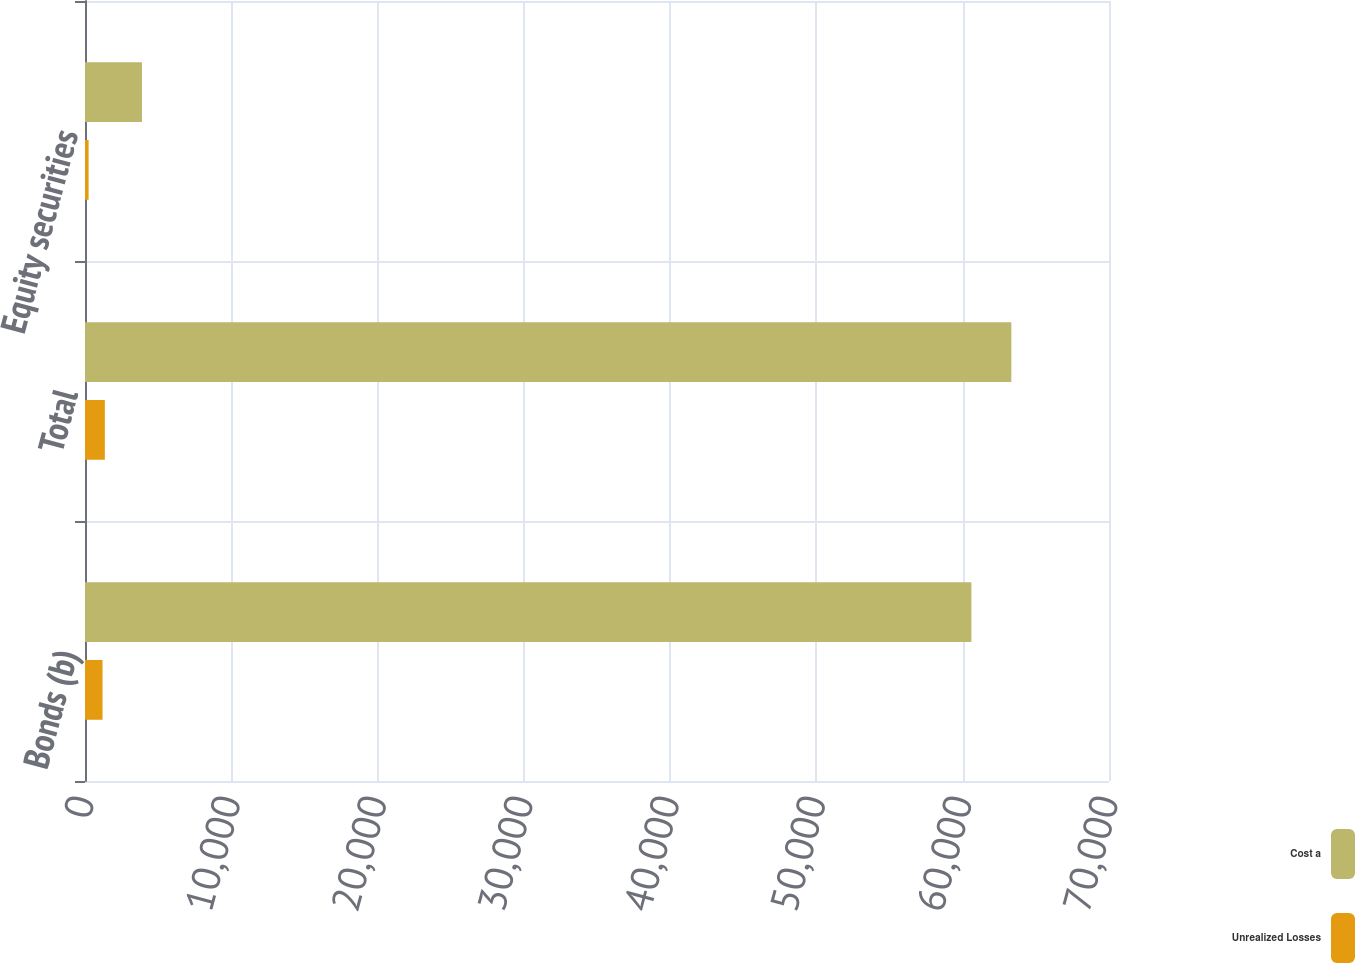Convert chart. <chart><loc_0><loc_0><loc_500><loc_500><stacked_bar_chart><ecel><fcel>Bonds (b)<fcel>Total<fcel>Equity securities<nl><fcel>Cost a<fcel>60591<fcel>63325<fcel>3894<nl><fcel>Unrealized Losses<fcel>1197<fcel>1356<fcel>246<nl></chart> 